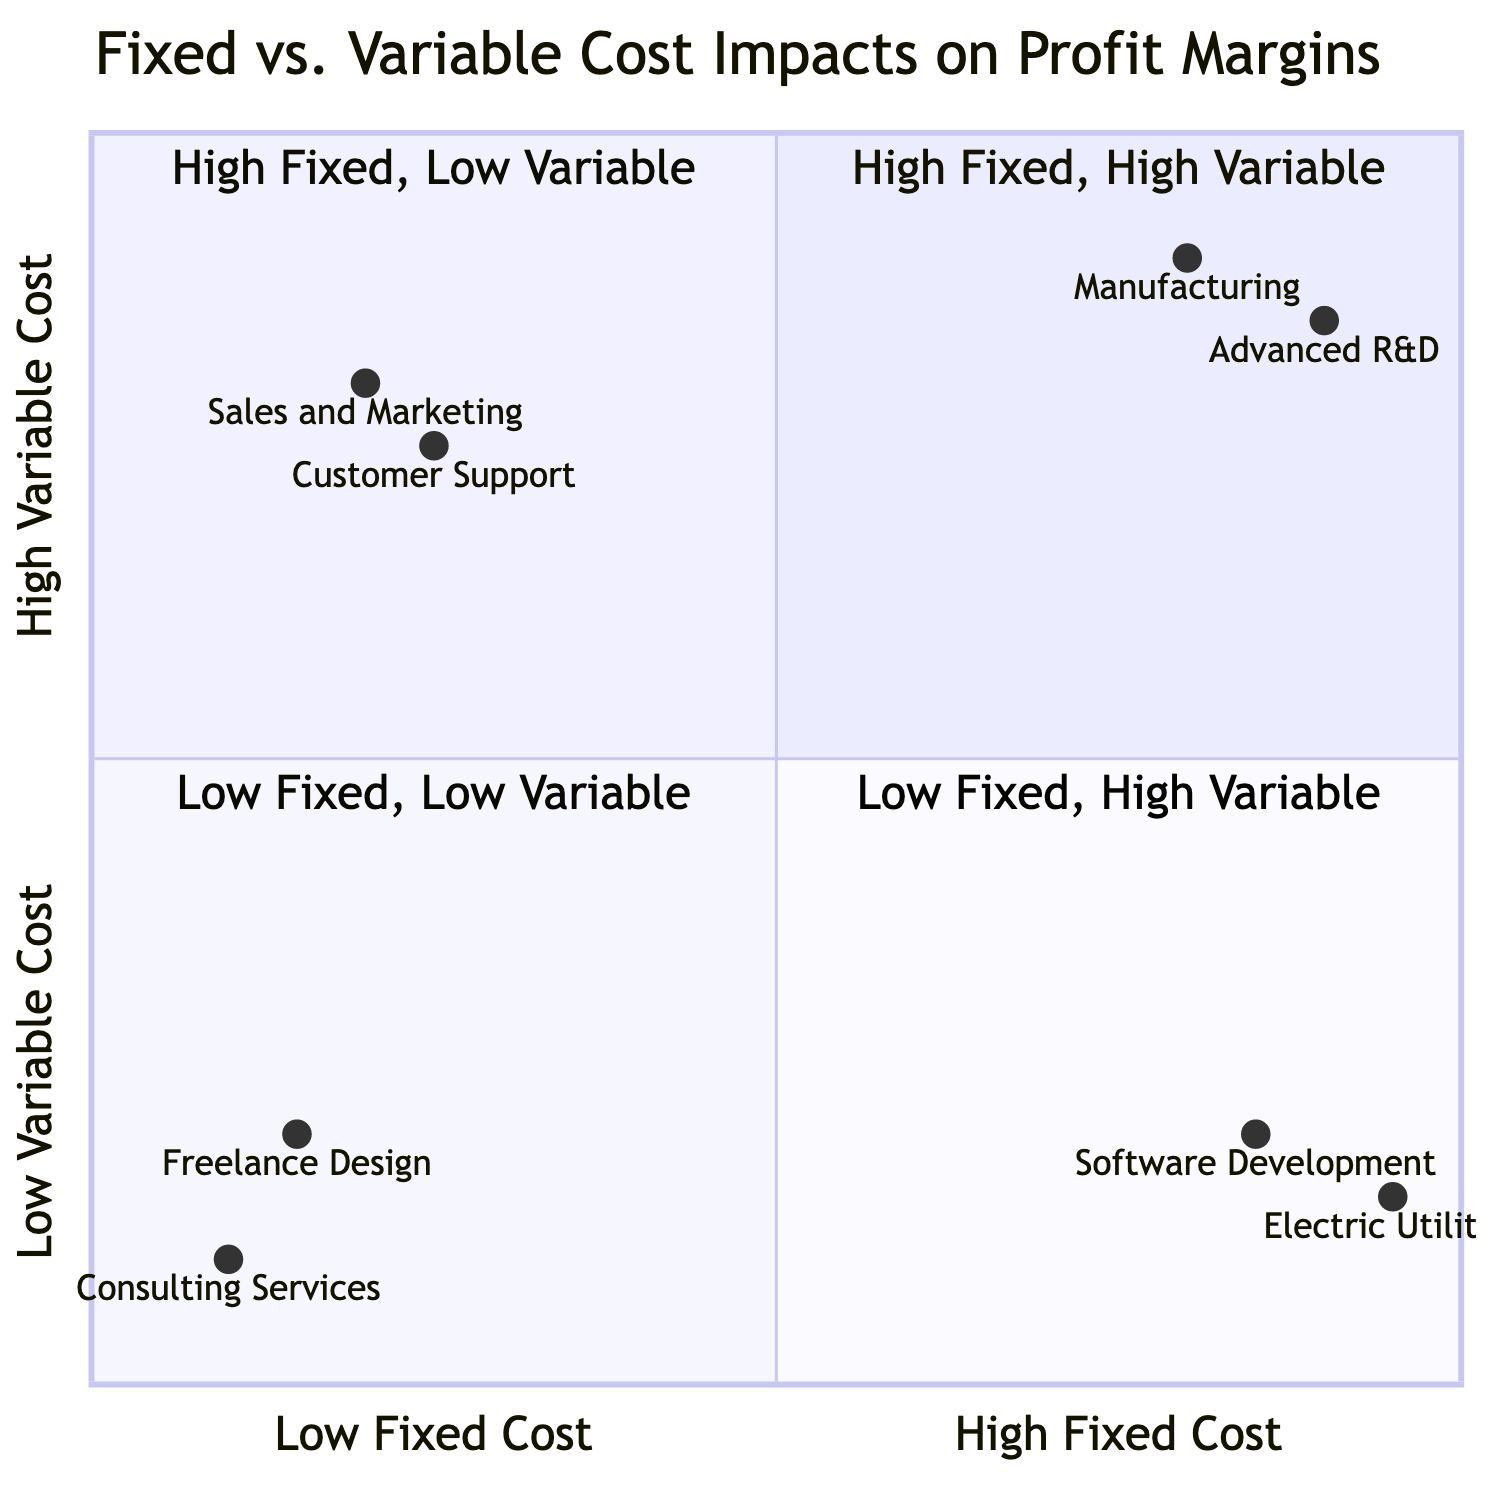What examples are in the "High Fixed Cost, High Variable Cost" quadrant? The quadrant labeled "High Fixed Cost, High Variable Cost" includes the examples of "Manufacturing" and "Advanced Research and Development." This information can be directly found in the quadrant description.
Answer: Manufacturing, Advanced Research and Development What is the profit margin category for "Consulting Services"? In the quadrant labeled "Low Fixed Cost, Low Variable Cost," which includes "Consulting Services," the profit margin is categorized as "High." This information is provided in the impacts section of the quadrant.
Answer: High What departments are associated with "Low Fixed Cost, High Variable Cost"? The departments classified under the "Low Fixed Cost, High Variable Cost" quadrant are "Sales and Marketing" and "Customer Support." This can be answered by looking at the examples listed in that specific quadrant.
Answer: Sales and Marketing, Customer Support What is the risk level for the "Software Development" department? The "Software Development" department falls under the "High Fixed Cost, Low Variable Cost" quadrant, where the risk level is stated to be "Medium." This detail is specifically mentioned in the impacts section of that quadrant.
Answer: Medium Which quadrant has the lowest risk? The "Low Fixed Cost, Low Variable Cost" quadrant has the lowest risk, categorized as "Low." This can be determined by evaluating the risk levels assigned to each quadrant.
Answer: Low What is the profit margin for departments with high fixed costs and low variable costs? Departments characterized as having high fixed costs and low variable costs (such as "Software Development" and "Electric Utilities") have a profit margin categorized as "Medium to High." This is stated in the respective quadrant's impacts section.
Answer: Medium to High What is the relationship between fixed costs and profit margin in the "High Fixed Cost, High Variable Cost" quadrant? In the "High Fixed Cost, High Variable Cost" quadrant, there is a direct relationship where the departments face "Low to Medium" profit margins due to high both fixed and variable costs, indicating they struggle with scalability.
Answer: Low to Medium How many examples are in the "Low Fixed Cost, Low Variable Cost" quadrant? The "Low Fixed Cost, Low Variable Cost" quadrant lists two examples: "Consulting Services" and "Freelance Design." Counting the examples provided confirms there are two.
Answer: Two 